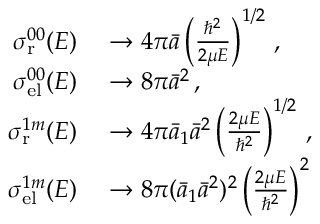<formula> <loc_0><loc_0><loc_500><loc_500>\begin{array} { r l } { \sigma _ { r } ^ { 0 0 } ( E ) } & \to 4 \pi \bar { a } \left ( \frac { \hbar { ^ } { 2 } } { 2 \mu E } \right ) ^ { 1 / 2 } \, , } \\ { \sigma _ { e l } ^ { 0 0 } ( E ) } & \to 8 \pi { \bar { a } } ^ { 2 } \, , } \\ { \sigma _ { r } ^ { 1 m } ( E ) } & \to 4 \pi \bar { a } _ { 1 } { \bar { a } } ^ { 2 } \left ( \frac { 2 \mu E } { \hbar { ^ } { 2 } } \right ) ^ { 1 / 2 } \, , } \\ { \sigma _ { e l } ^ { 1 m } ( E ) } & \to 8 \pi ( \bar { a } _ { 1 } { \bar { a } } ^ { 2 } ) ^ { 2 } \left ( \frac { 2 \mu E } { \hbar { ^ } { 2 } } \right ) ^ { 2 } } \end{array}</formula> 